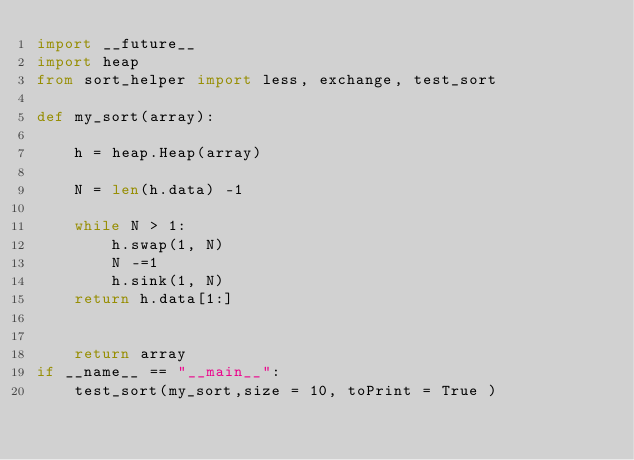Convert code to text. <code><loc_0><loc_0><loc_500><loc_500><_Python_>import __future__
import heap
from sort_helper import less, exchange, test_sort

def my_sort(array):

    h = heap.Heap(array)

    N = len(h.data) -1

    while N > 1:
        h.swap(1, N)
        N -=1
        h.sink(1, N) 
    return h.data[1:]


    return array
if __name__ == "__main__":
    test_sort(my_sort,size = 10, toPrint = True )

</code> 